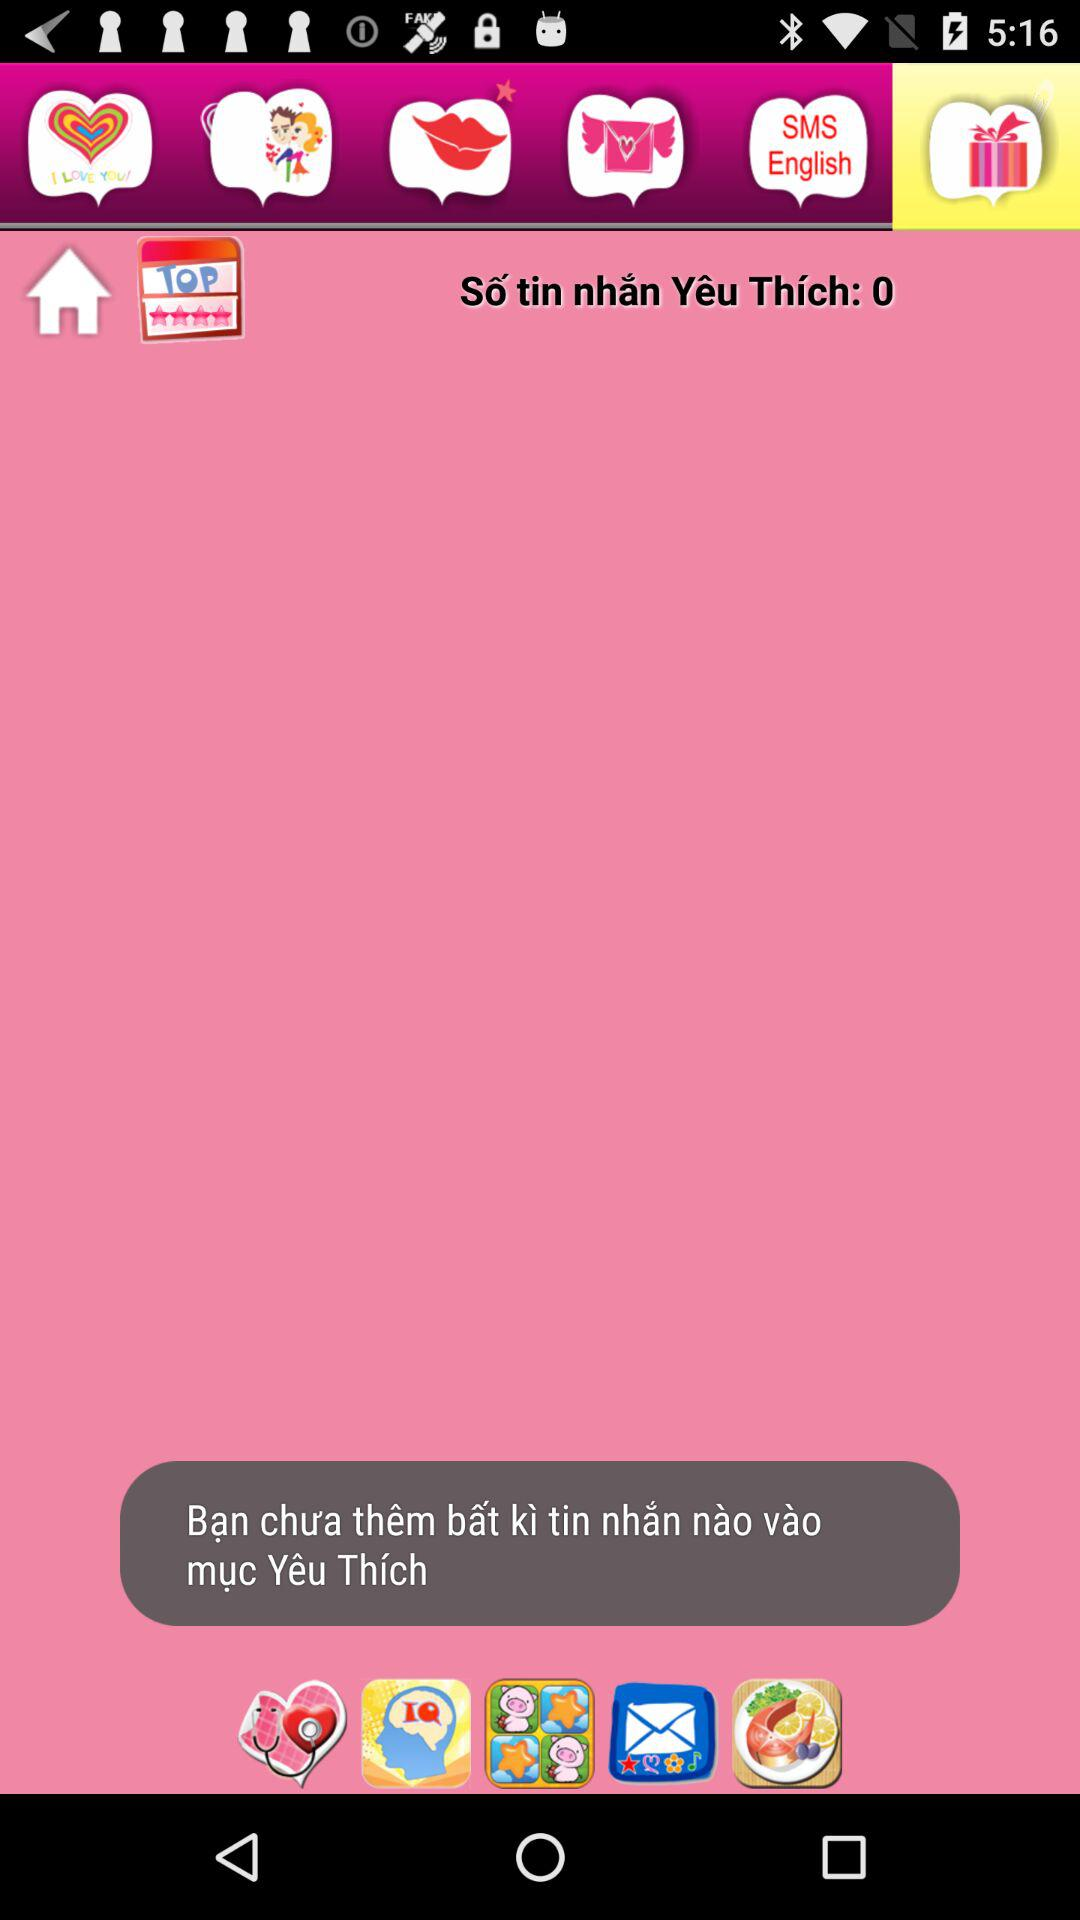How many messages are in my Favorites folder?
Answer the question using a single word or phrase. 0 